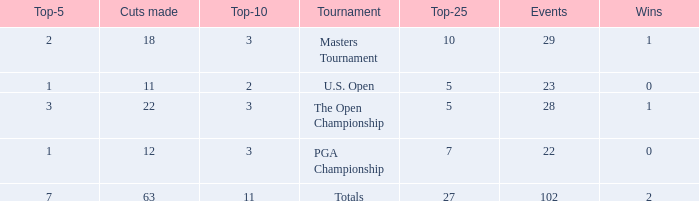How many times did he achieve a top 10 rank when he had less than one top 5 rank? None. 